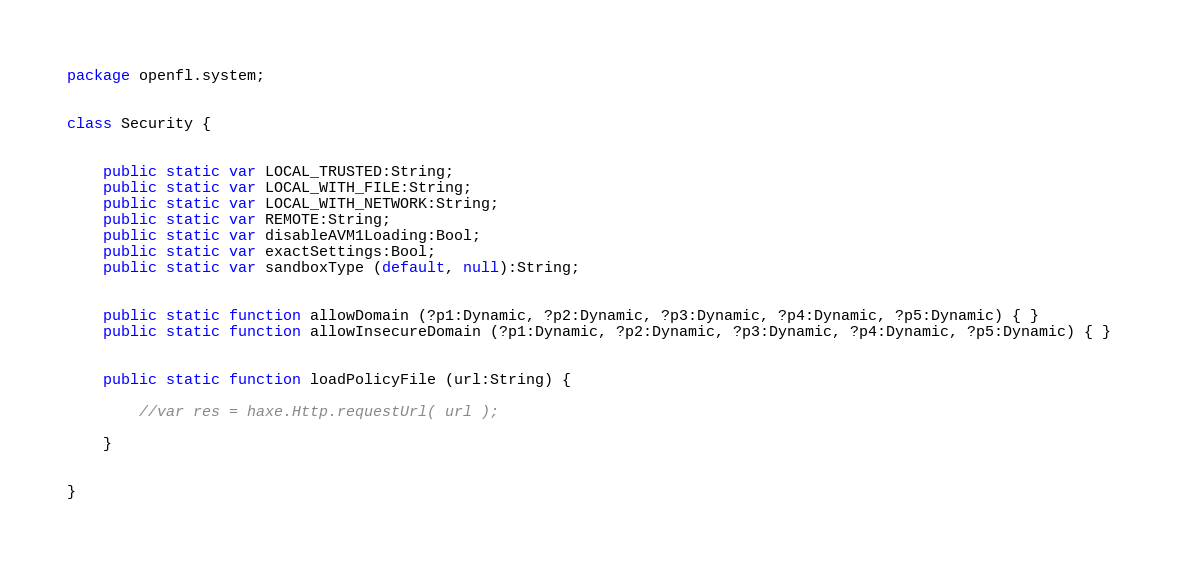Convert code to text. <code><loc_0><loc_0><loc_500><loc_500><_Haxe_>package openfl.system;


class Security {
	
	
	public static var LOCAL_TRUSTED:String;
	public static var LOCAL_WITH_FILE:String;
	public static var LOCAL_WITH_NETWORK:String;
	public static var REMOTE:String;
	public static var disableAVM1Loading:Bool;
	public static var exactSettings:Bool;
	public static var sandboxType (default, null):String;
	
	
	public static function allowDomain (?p1:Dynamic, ?p2:Dynamic, ?p3:Dynamic, ?p4:Dynamic, ?p5:Dynamic) { }
	public static function allowInsecureDomain (?p1:Dynamic, ?p2:Dynamic, ?p3:Dynamic, ?p4:Dynamic, ?p5:Dynamic) { }
	
	
	public static function loadPolicyFile (url:String) {
		
		//var res = haxe.Http.requestUrl( url );
		
	}
	
	
}</code> 